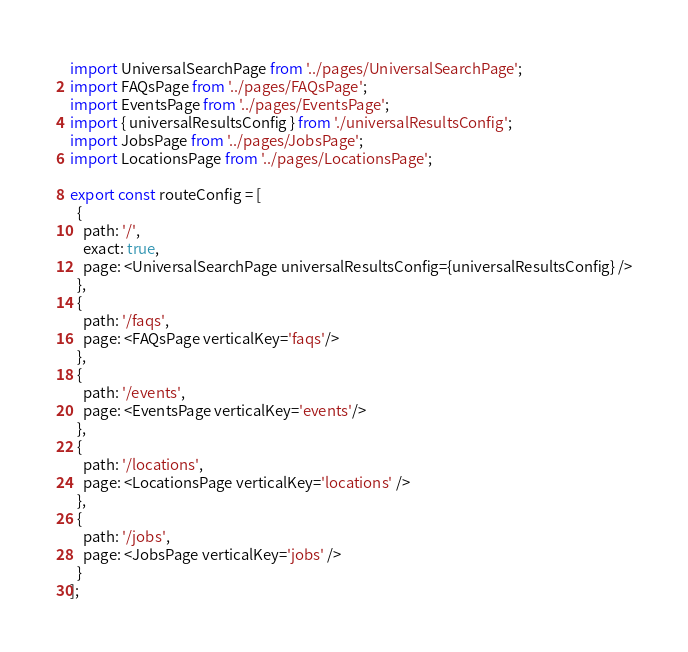<code> <loc_0><loc_0><loc_500><loc_500><_TypeScript_>import UniversalSearchPage from '../pages/UniversalSearchPage';
import FAQsPage from '../pages/FAQsPage';
import EventsPage from '../pages/EventsPage';
import { universalResultsConfig } from './universalResultsConfig';
import JobsPage from '../pages/JobsPage';
import LocationsPage from '../pages/LocationsPage'; 

export const routeConfig = [
  {
    path: '/',
    exact: true,
    page: <UniversalSearchPage universalResultsConfig={universalResultsConfig} />
  },
  {
    path: '/faqs',
    page: <FAQsPage verticalKey='faqs'/>
  },
  {
    path: '/events',
    page: <EventsPage verticalKey='events'/>
  },
  {
    path: '/locations',
    page: <LocationsPage verticalKey='locations' />
  },
  {
    path: '/jobs',
    page: <JobsPage verticalKey='jobs' />
  }
];</code> 